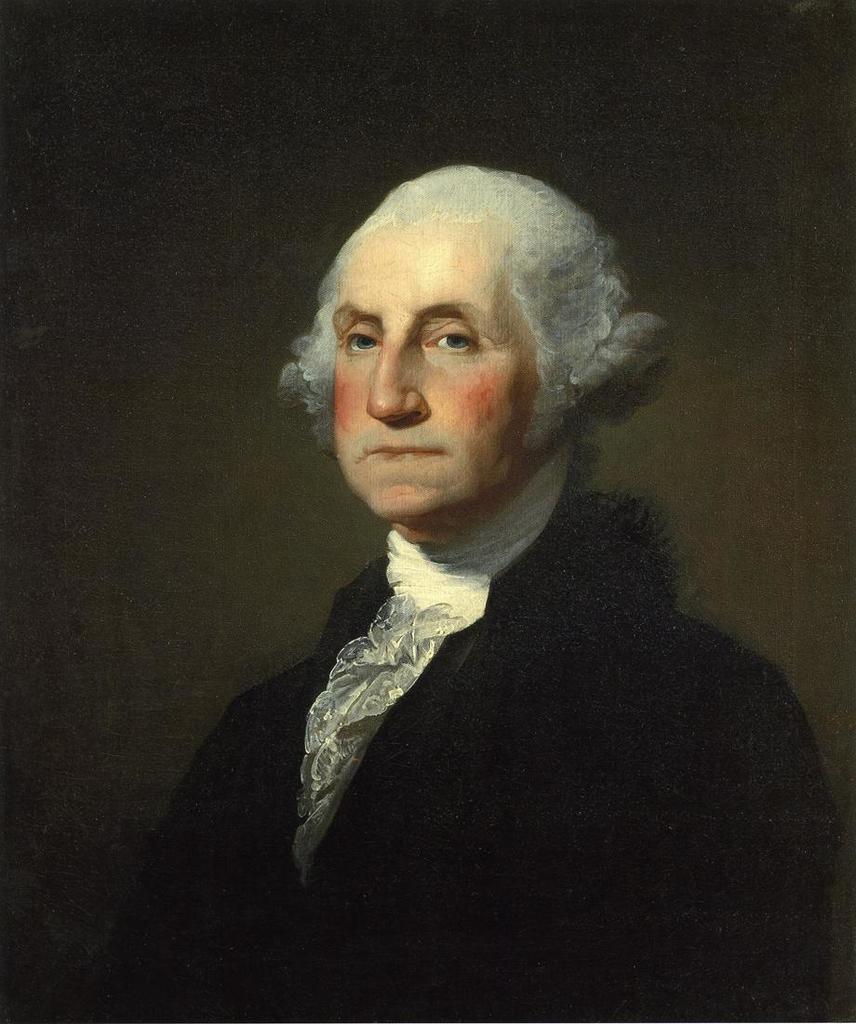Describe this image in one or two sentences. In this image I can see depiction of a man wearing black colour dress. I can also see black colour in background. 